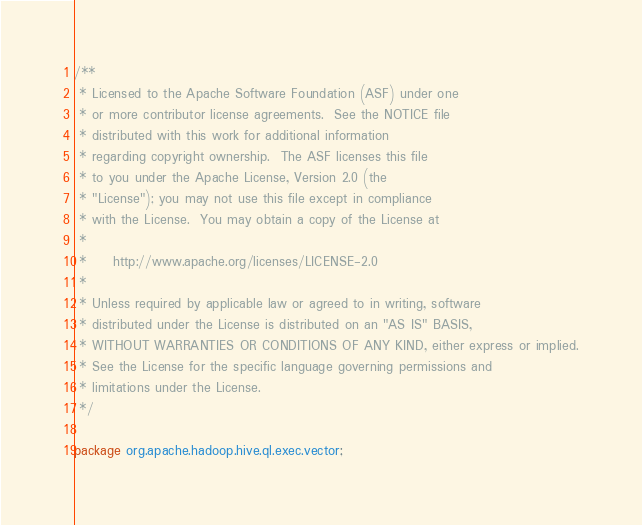Convert code to text. <code><loc_0><loc_0><loc_500><loc_500><_Java_>/**
 * Licensed to the Apache Software Foundation (ASF) under one
 * or more contributor license agreements.  See the NOTICE file
 * distributed with this work for additional information
 * regarding copyright ownership.  The ASF licenses this file
 * to you under the Apache License, Version 2.0 (the
 * "License"); you may not use this file except in compliance
 * with the License.  You may obtain a copy of the License at
 *
 *     http://www.apache.org/licenses/LICENSE-2.0
 *
 * Unless required by applicable law or agreed to in writing, software
 * distributed under the License is distributed on an "AS IS" BASIS,
 * WITHOUT WARRANTIES OR CONDITIONS OF ANY KIND, either express or implied.
 * See the License for the specific language governing permissions and
 * limitations under the License.
 */

package org.apache.hadoop.hive.ql.exec.vector;
</code> 